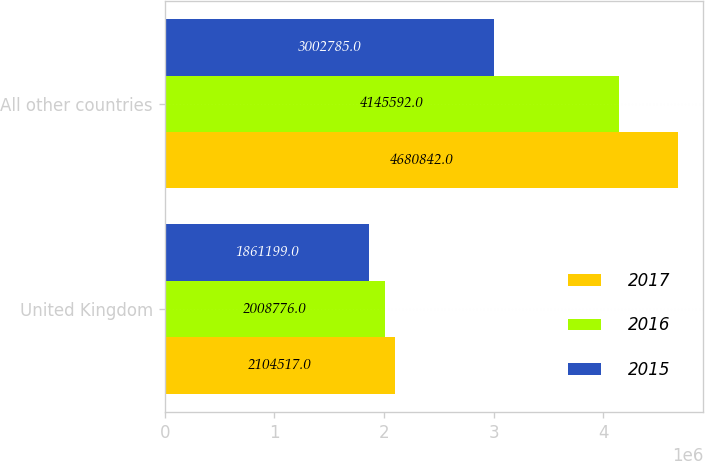Convert chart to OTSL. <chart><loc_0><loc_0><loc_500><loc_500><stacked_bar_chart><ecel><fcel>United Kingdom<fcel>All other countries<nl><fcel>2017<fcel>2.10452e+06<fcel>4.68084e+06<nl><fcel>2016<fcel>2.00878e+06<fcel>4.14559e+06<nl><fcel>2015<fcel>1.8612e+06<fcel>3.00278e+06<nl></chart> 